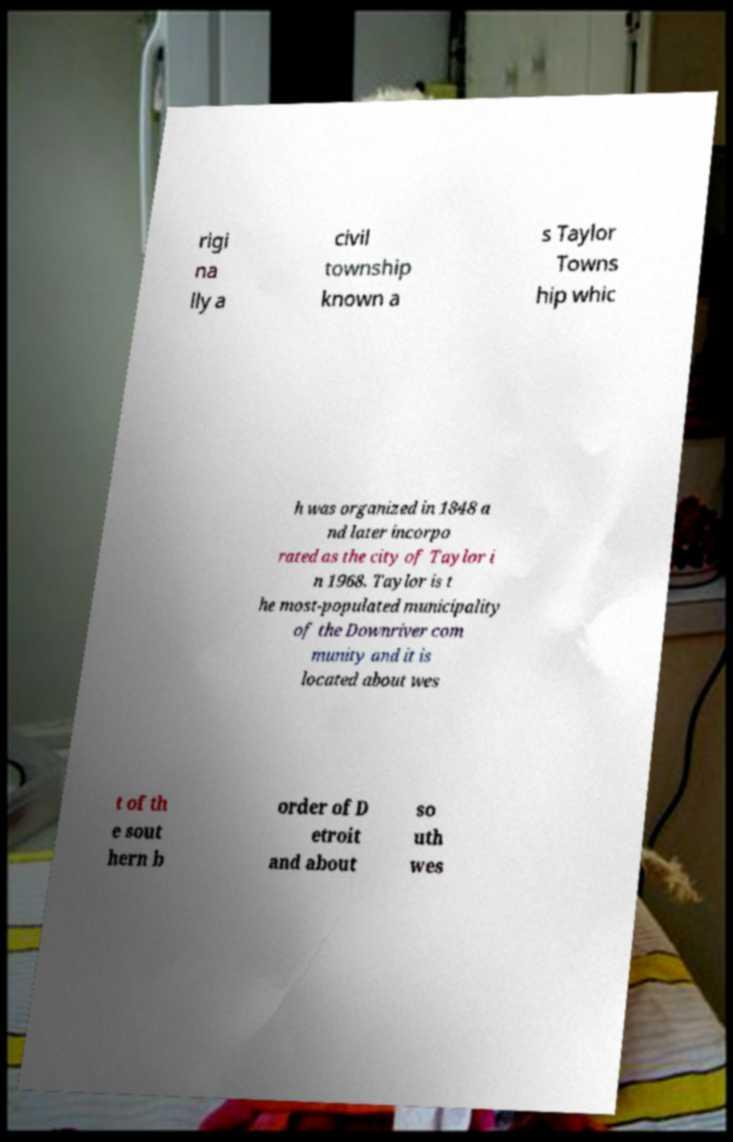Can you read and provide the text displayed in the image?This photo seems to have some interesting text. Can you extract and type it out for me? rigi na lly a civil township known a s Taylor Towns hip whic h was organized in 1848 a nd later incorpo rated as the city of Taylor i n 1968. Taylor is t he most-populated municipality of the Downriver com munity and it is located about wes t of th e sout hern b order of D etroit and about so uth wes 